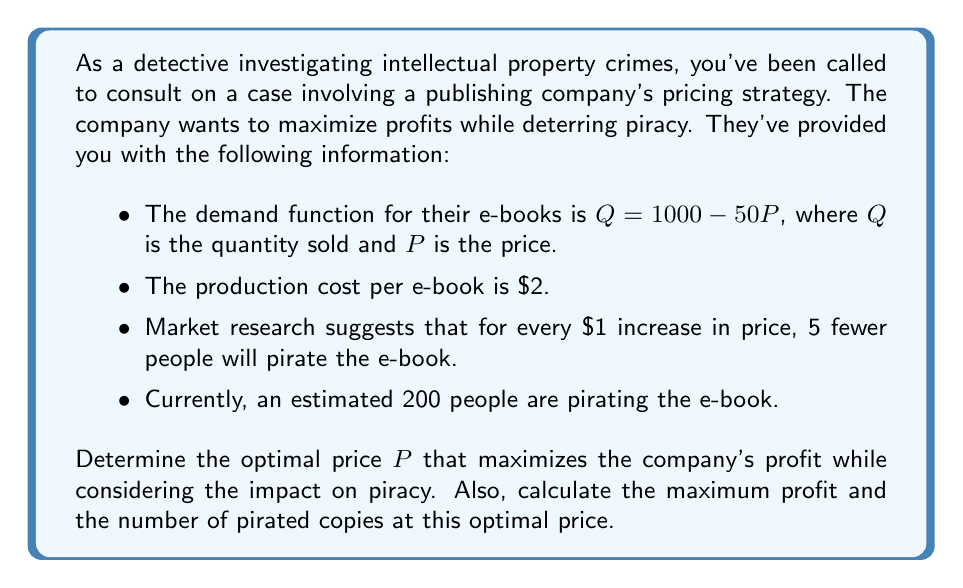Provide a solution to this math problem. Let's approach this step-by-step:

1) First, let's define our profit function. Profit is revenue minus cost:
   $$ \text{Profit} = \text{Revenue} - \text{Cost} $$

2) Revenue is price times quantity: $P \cdot Q$
   Cost is the production cost per unit times quantity: $2Q$
   So our profit function is:
   $$ \text{Profit} = P \cdot Q - 2Q $$

3) We know that $Q = 1000 - 50P$, so let's substitute this:
   $$ \text{Profit} = P(1000 - 50P) - 2(1000 - 50P) $$
   $$ = 1000P - 50P^2 - 2000 + 100P $$
   $$ = 1100P - 50P^2 - 2000 $$

4) To find the maximum profit, we need to differentiate this function with respect to P and set it to zero:
   $$ \frac{d(\text{Profit})}{dP} = 1100 - 100P = 0 $$
   $$ 100P = 1100 $$
   $$ P = 11 $$

5) This gives us the optimal price of $\$11$. Let's verify it's a maximum by checking the second derivative:
   $$ \frac{d^2(\text{Profit})}{dP^2} = -100 $$
   This is negative, confirming we have a maximum.

6) Now, let's calculate the profit at this price:
   $$ Q = 1000 - 50(11) = 450 $$
   $$ \text{Profit} = 11 \cdot 450 - 2 \cdot 450 = 4050 $$

7) Finally, let's consider piracy. Initially, 200 people were pirating. For every $\$1$ increase in price, 5 fewer people pirate. The price increased by $\$11$, so:
   $$ \text{Pirated copies} = 200 - (5 \cdot 11) = 145 $$

Therefore, the optimal price is $\$11$, which results in a maximum profit of $\$4050$ and reduces pirated copies to 145.
Answer: Optimal price: $\$11$
Maximum profit: $\$4050$
Pirated copies at optimal price: 145 